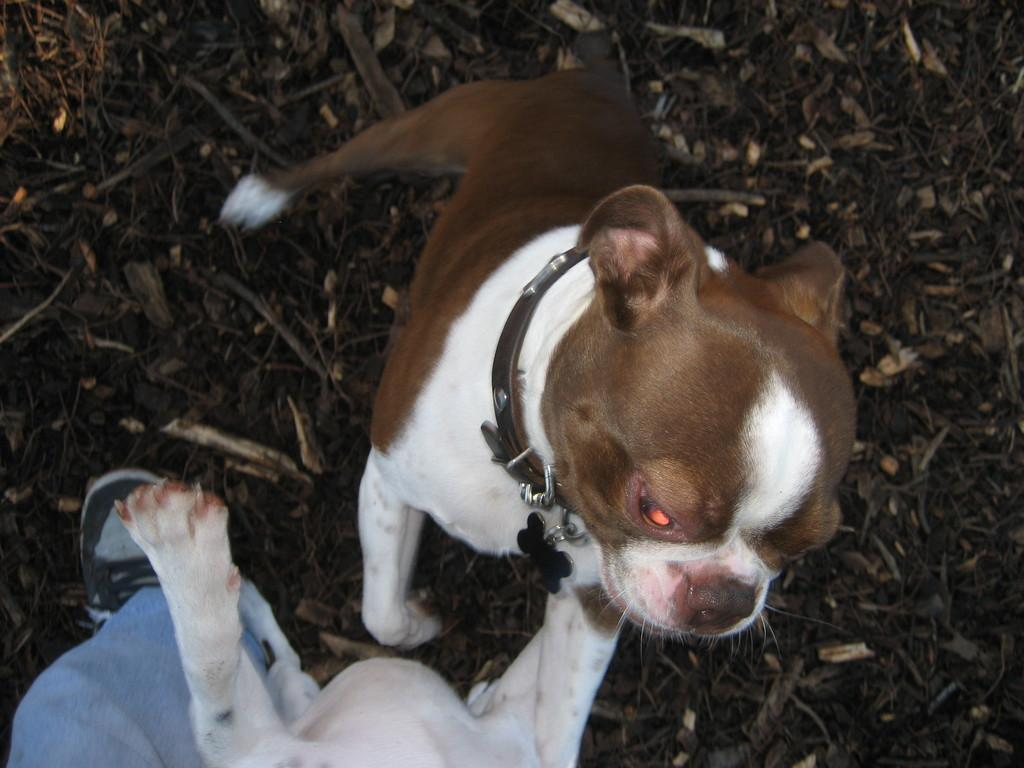What type of animals are present in the image? There are dogs in the image. What is the position of the dogs in the image? The dogs are standing on the ground. Are there any humans in the image? Yes, there is a person in the image. What type of copper material can be seen in the image? There is no copper material present in the image. How many cattle are visible in the image? There are no cattle present in the image. 